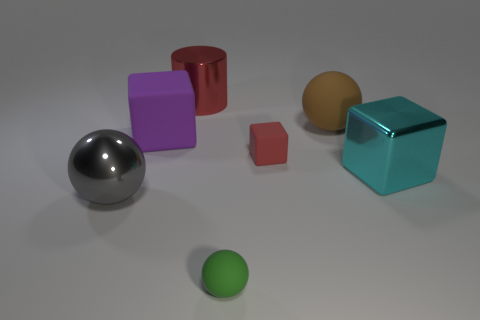Subtract all big cubes. How many cubes are left? 1 Add 2 big brown spheres. How many objects exist? 9 Subtract 1 spheres. How many spheres are left? 2 Subtract all red cubes. How many cubes are left? 2 Subtract all blocks. How many objects are left? 4 Subtract all blue spheres. Subtract all cyan cylinders. How many spheres are left? 3 Subtract all large blue blocks. Subtract all large objects. How many objects are left? 2 Add 2 cyan objects. How many cyan objects are left? 3 Add 2 purple things. How many purple things exist? 3 Subtract 1 cyan blocks. How many objects are left? 6 